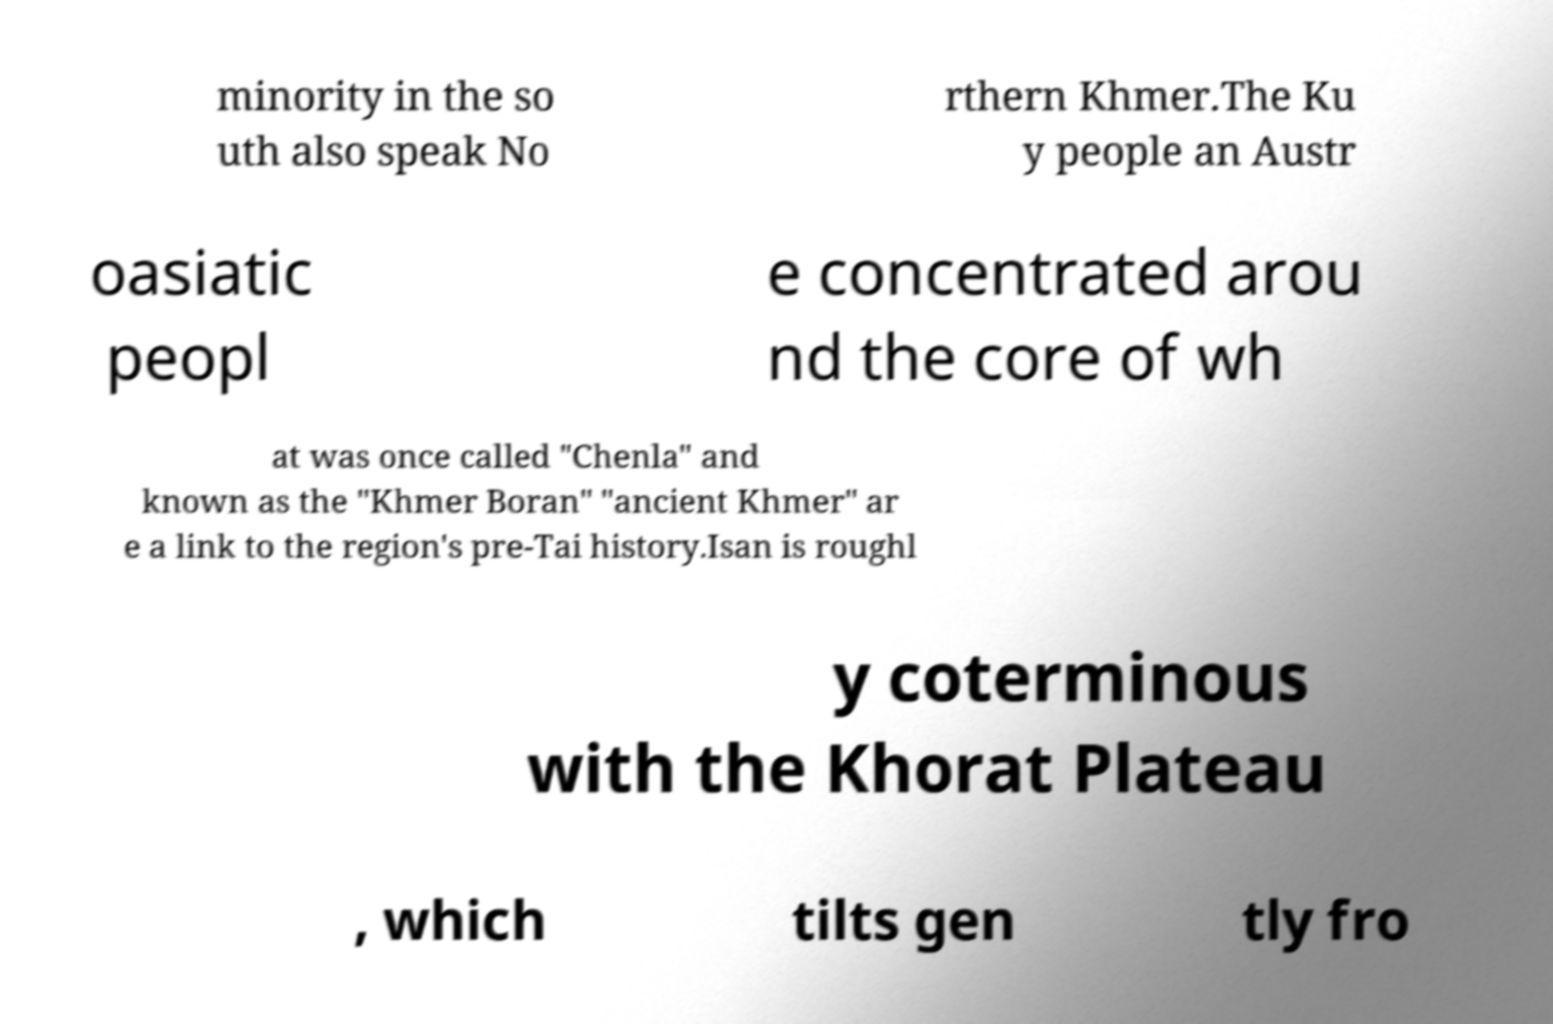I need the written content from this picture converted into text. Can you do that? minority in the so uth also speak No rthern Khmer.The Ku y people an Austr oasiatic peopl e concentrated arou nd the core of wh at was once called "Chenla" and known as the "Khmer Boran" "ancient Khmer" ar e a link to the region's pre-Tai history.Isan is roughl y coterminous with the Khorat Plateau , which tilts gen tly fro 